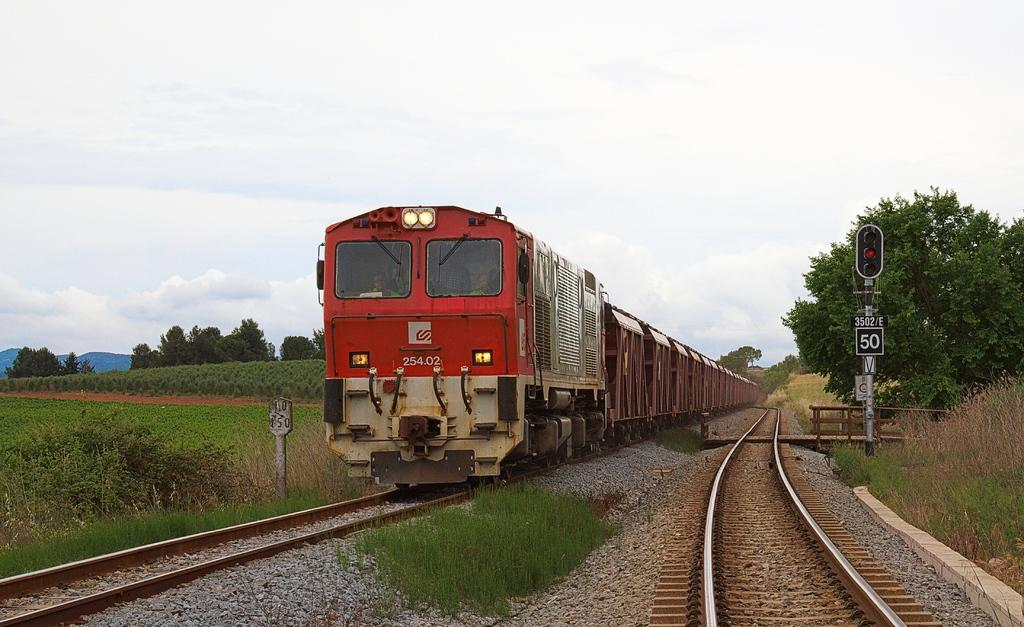Provide a one-sentence caption for the provided image. A red train has the code 254.02 on the front of it. 